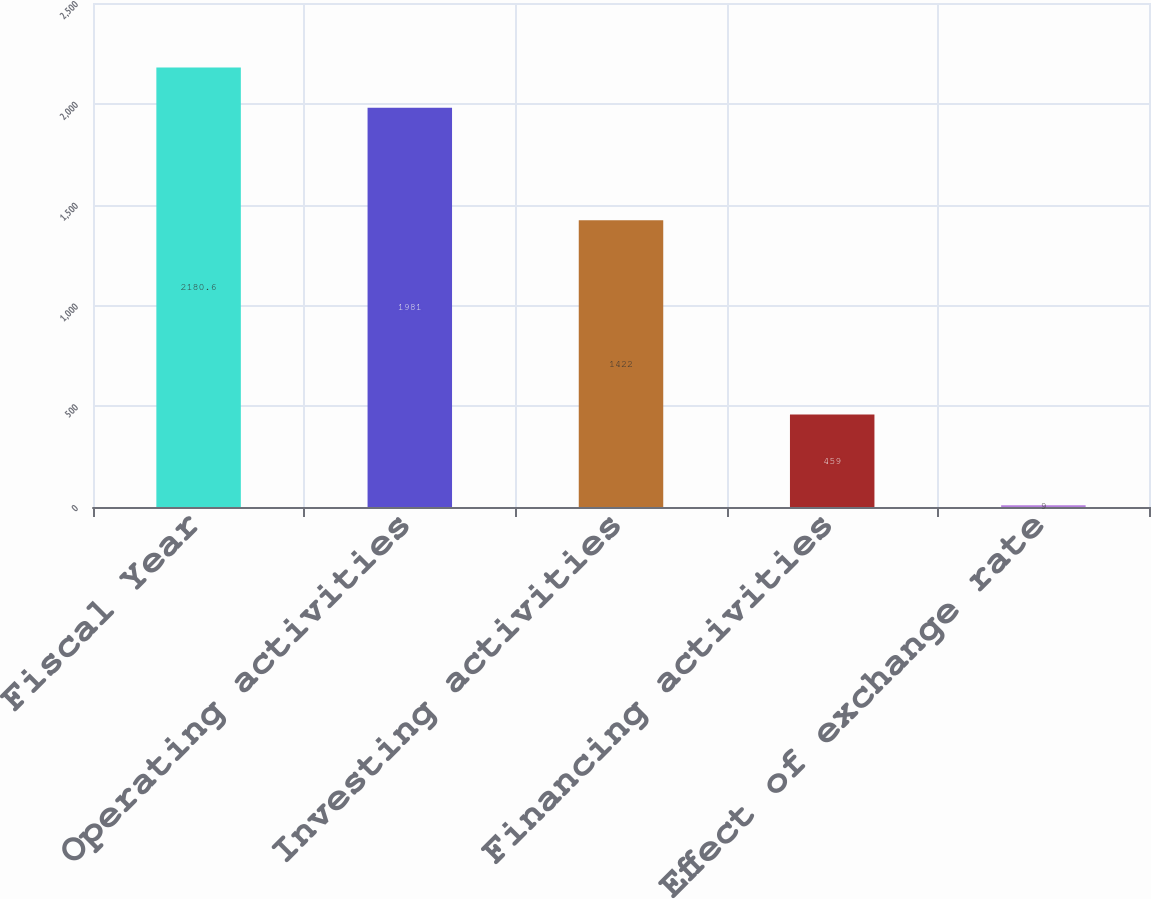<chart> <loc_0><loc_0><loc_500><loc_500><bar_chart><fcel>Fiscal Year<fcel>Operating activities<fcel>Investing activities<fcel>Financing activities<fcel>Effect of exchange rate<nl><fcel>2180.6<fcel>1981<fcel>1422<fcel>459<fcel>9<nl></chart> 